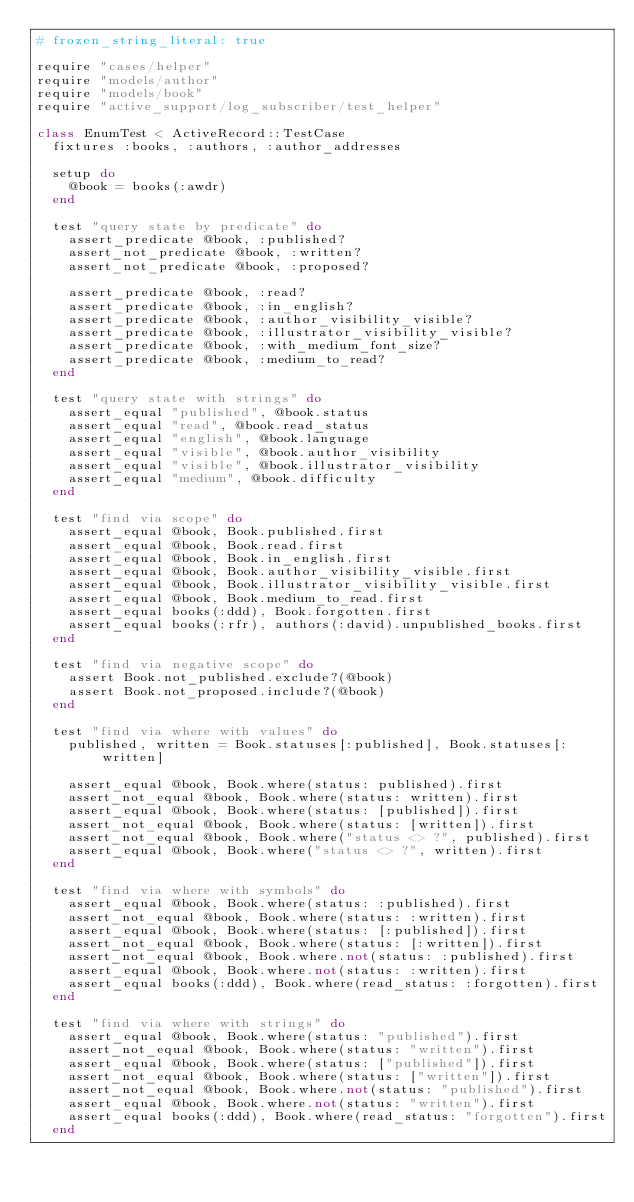<code> <loc_0><loc_0><loc_500><loc_500><_Ruby_># frozen_string_literal: true

require "cases/helper"
require "models/author"
require "models/book"
require "active_support/log_subscriber/test_helper"

class EnumTest < ActiveRecord::TestCase
  fixtures :books, :authors, :author_addresses

  setup do
    @book = books(:awdr)
  end

  test "query state by predicate" do
    assert_predicate @book, :published?
    assert_not_predicate @book, :written?
    assert_not_predicate @book, :proposed?

    assert_predicate @book, :read?
    assert_predicate @book, :in_english?
    assert_predicate @book, :author_visibility_visible?
    assert_predicate @book, :illustrator_visibility_visible?
    assert_predicate @book, :with_medium_font_size?
    assert_predicate @book, :medium_to_read?
  end

  test "query state with strings" do
    assert_equal "published", @book.status
    assert_equal "read", @book.read_status
    assert_equal "english", @book.language
    assert_equal "visible", @book.author_visibility
    assert_equal "visible", @book.illustrator_visibility
    assert_equal "medium", @book.difficulty
  end

  test "find via scope" do
    assert_equal @book, Book.published.first
    assert_equal @book, Book.read.first
    assert_equal @book, Book.in_english.first
    assert_equal @book, Book.author_visibility_visible.first
    assert_equal @book, Book.illustrator_visibility_visible.first
    assert_equal @book, Book.medium_to_read.first
    assert_equal books(:ddd), Book.forgotten.first
    assert_equal books(:rfr), authors(:david).unpublished_books.first
  end

  test "find via negative scope" do
    assert Book.not_published.exclude?(@book)
    assert Book.not_proposed.include?(@book)
  end

  test "find via where with values" do
    published, written = Book.statuses[:published], Book.statuses[:written]

    assert_equal @book, Book.where(status: published).first
    assert_not_equal @book, Book.where(status: written).first
    assert_equal @book, Book.where(status: [published]).first
    assert_not_equal @book, Book.where(status: [written]).first
    assert_not_equal @book, Book.where("status <> ?", published).first
    assert_equal @book, Book.where("status <> ?", written).first
  end

  test "find via where with symbols" do
    assert_equal @book, Book.where(status: :published).first
    assert_not_equal @book, Book.where(status: :written).first
    assert_equal @book, Book.where(status: [:published]).first
    assert_not_equal @book, Book.where(status: [:written]).first
    assert_not_equal @book, Book.where.not(status: :published).first
    assert_equal @book, Book.where.not(status: :written).first
    assert_equal books(:ddd), Book.where(read_status: :forgotten).first
  end

  test "find via where with strings" do
    assert_equal @book, Book.where(status: "published").first
    assert_not_equal @book, Book.where(status: "written").first
    assert_equal @book, Book.where(status: ["published"]).first
    assert_not_equal @book, Book.where(status: ["written"]).first
    assert_not_equal @book, Book.where.not(status: "published").first
    assert_equal @book, Book.where.not(status: "written").first
    assert_equal books(:ddd), Book.where(read_status: "forgotten").first
  end
</code> 